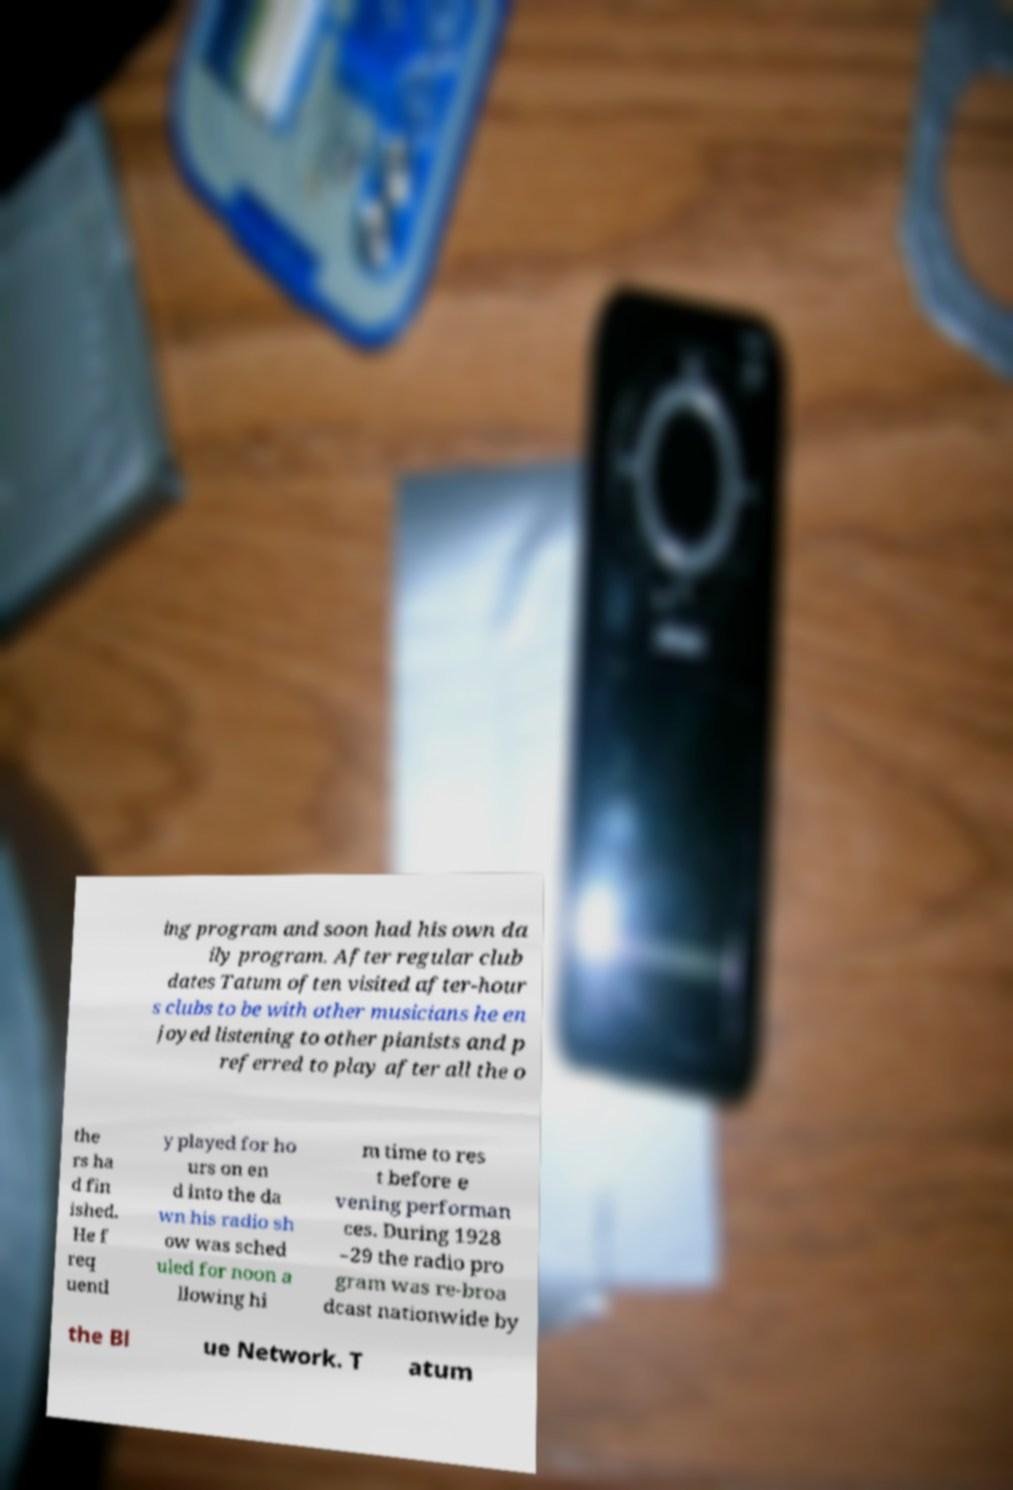Could you assist in decoding the text presented in this image and type it out clearly? ing program and soon had his own da ily program. After regular club dates Tatum often visited after-hour s clubs to be with other musicians he en joyed listening to other pianists and p referred to play after all the o the rs ha d fin ished. He f req uentl y played for ho urs on en d into the da wn his radio sh ow was sched uled for noon a llowing hi m time to res t before e vening performan ces. During 1928 –29 the radio pro gram was re-broa dcast nationwide by the Bl ue Network. T atum 